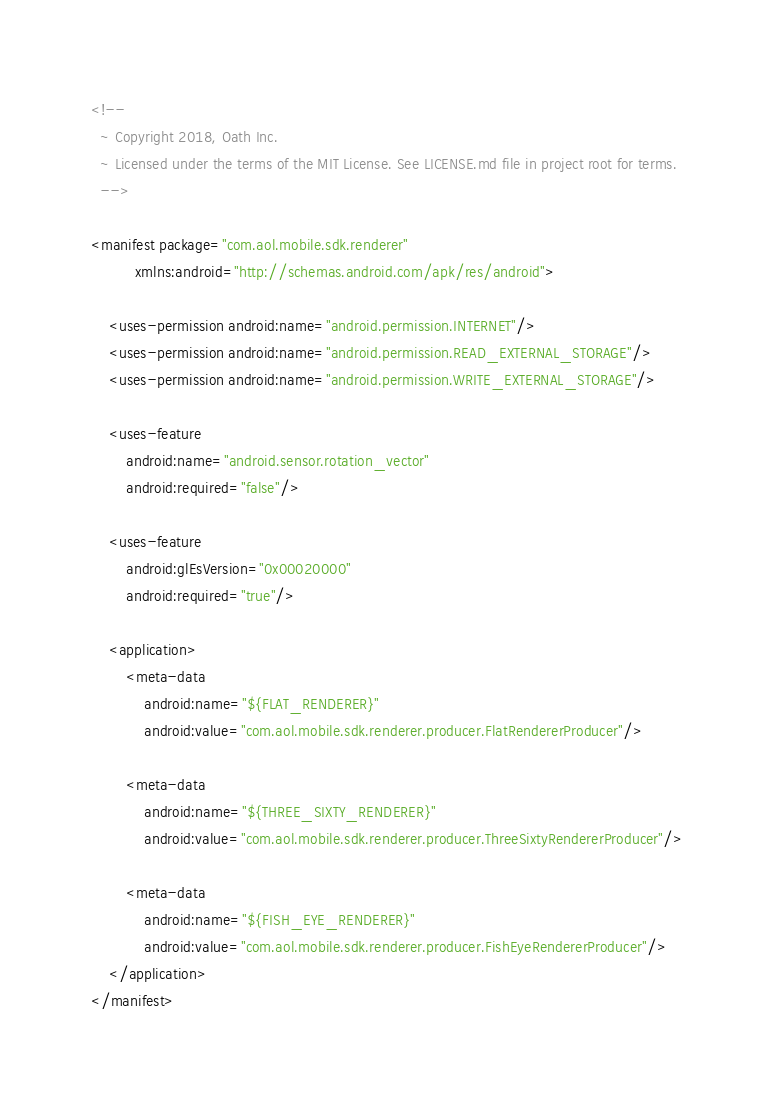<code> <loc_0><loc_0><loc_500><loc_500><_XML_><!--
  ~ Copyright 2018, Oath Inc.
  ~ Licensed under the terms of the MIT License. See LICENSE.md file in project root for terms.
  -->

<manifest package="com.aol.mobile.sdk.renderer"
          xmlns:android="http://schemas.android.com/apk/res/android">

    <uses-permission android:name="android.permission.INTERNET"/>
    <uses-permission android:name="android.permission.READ_EXTERNAL_STORAGE"/>
    <uses-permission android:name="android.permission.WRITE_EXTERNAL_STORAGE"/>

    <uses-feature
        android:name="android.sensor.rotation_vector"
        android:required="false"/>

    <uses-feature
        android:glEsVersion="0x00020000"
        android:required="true"/>

    <application>
        <meta-data
            android:name="${FLAT_RENDERER}"
            android:value="com.aol.mobile.sdk.renderer.producer.FlatRendererProducer"/>

        <meta-data
            android:name="${THREE_SIXTY_RENDERER}"
            android:value="com.aol.mobile.sdk.renderer.producer.ThreeSixtyRendererProducer"/>

        <meta-data
            android:name="${FISH_EYE_RENDERER}"
            android:value="com.aol.mobile.sdk.renderer.producer.FishEyeRendererProducer"/>
    </application>
</manifest>
</code> 